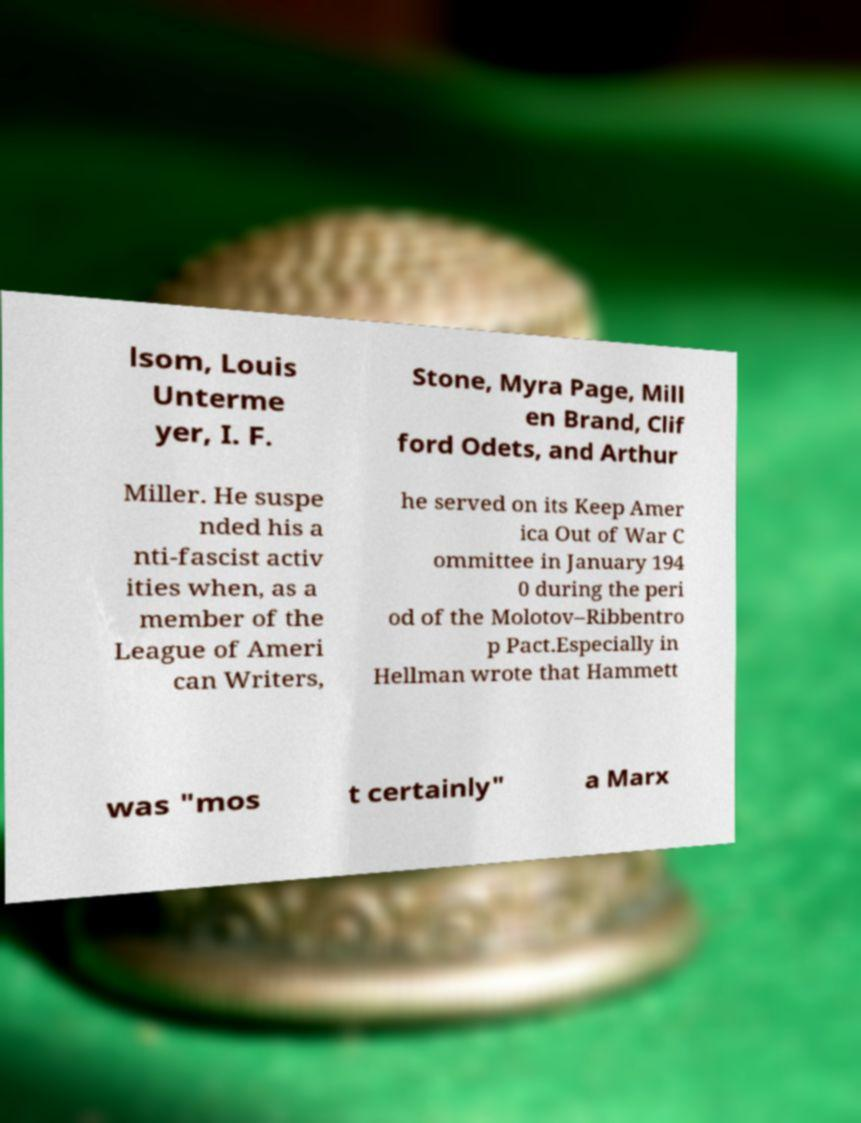Could you assist in decoding the text presented in this image and type it out clearly? lsom, Louis Unterme yer, I. F. Stone, Myra Page, Mill en Brand, Clif ford Odets, and Arthur Miller. He suspe nded his a nti-fascist activ ities when, as a member of the League of Ameri can Writers, he served on its Keep Amer ica Out of War C ommittee in January 194 0 during the peri od of the Molotov–Ribbentro p Pact.Especially in Hellman wrote that Hammett was "mos t certainly" a Marx 